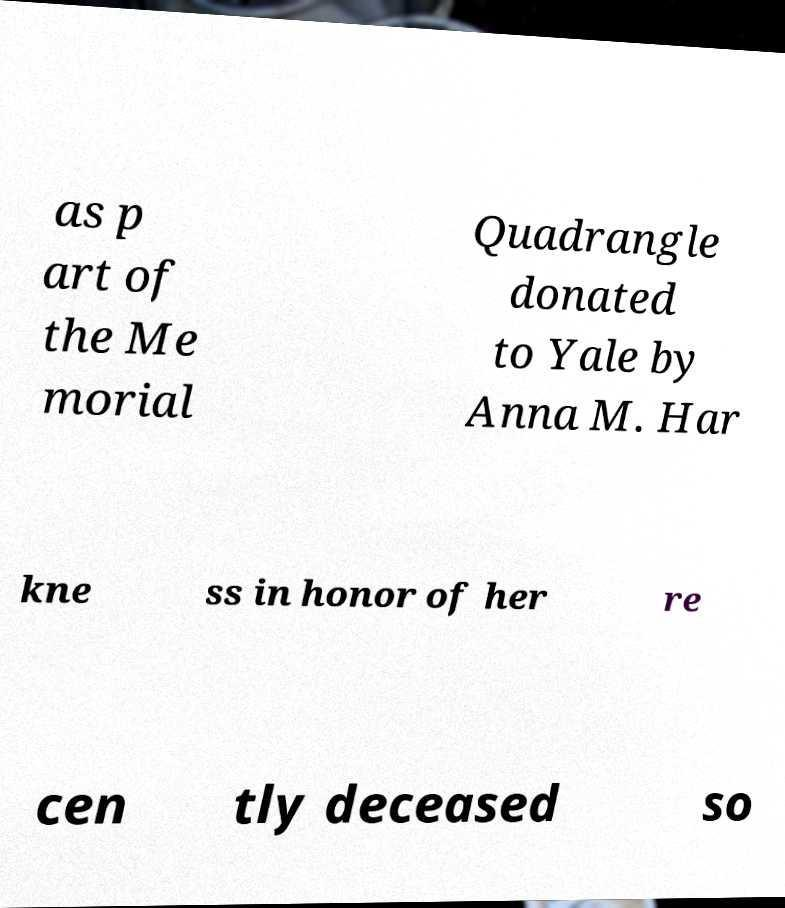Could you extract and type out the text from this image? as p art of the Me morial Quadrangle donated to Yale by Anna M. Har kne ss in honor of her re cen tly deceased so 